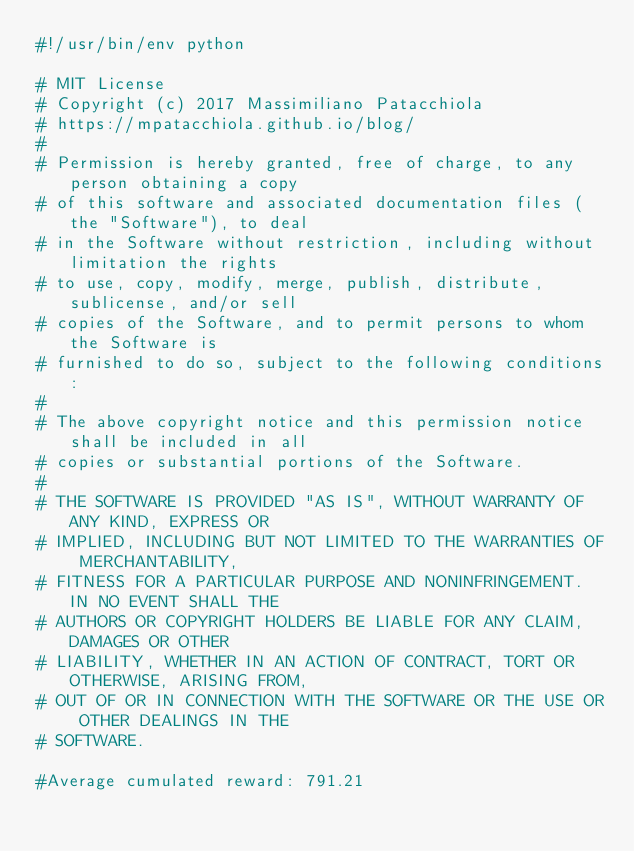<code> <loc_0><loc_0><loc_500><loc_500><_Python_>#!/usr/bin/env python

# MIT License
# Copyright (c) 2017 Massimiliano Patacchiola
# https://mpatacchiola.github.io/blog/
#
# Permission is hereby granted, free of charge, to any person obtaining a copy
# of this software and associated documentation files (the "Software"), to deal
# in the Software without restriction, including without limitation the rights
# to use, copy, modify, merge, publish, distribute, sublicense, and/or sell
# copies of the Software, and to permit persons to whom the Software is
# furnished to do so, subject to the following conditions:
#
# The above copyright notice and this permission notice shall be included in all
# copies or substantial portions of the Software.
#
# THE SOFTWARE IS PROVIDED "AS IS", WITHOUT WARRANTY OF ANY KIND, EXPRESS OR
# IMPLIED, INCLUDING BUT NOT LIMITED TO THE WARRANTIES OF MERCHANTABILITY,
# FITNESS FOR A PARTICULAR PURPOSE AND NONINFRINGEMENT. IN NO EVENT SHALL THE
# AUTHORS OR COPYRIGHT HOLDERS BE LIABLE FOR ANY CLAIM, DAMAGES OR OTHER
# LIABILITY, WHETHER IN AN ACTION OF CONTRACT, TORT OR OTHERWISE, ARISING FROM,
# OUT OF OR IN CONNECTION WITH THE SOFTWARE OR THE USE OR OTHER DEALINGS IN THE
# SOFTWARE.

#Average cumulated reward: 791.21</code> 